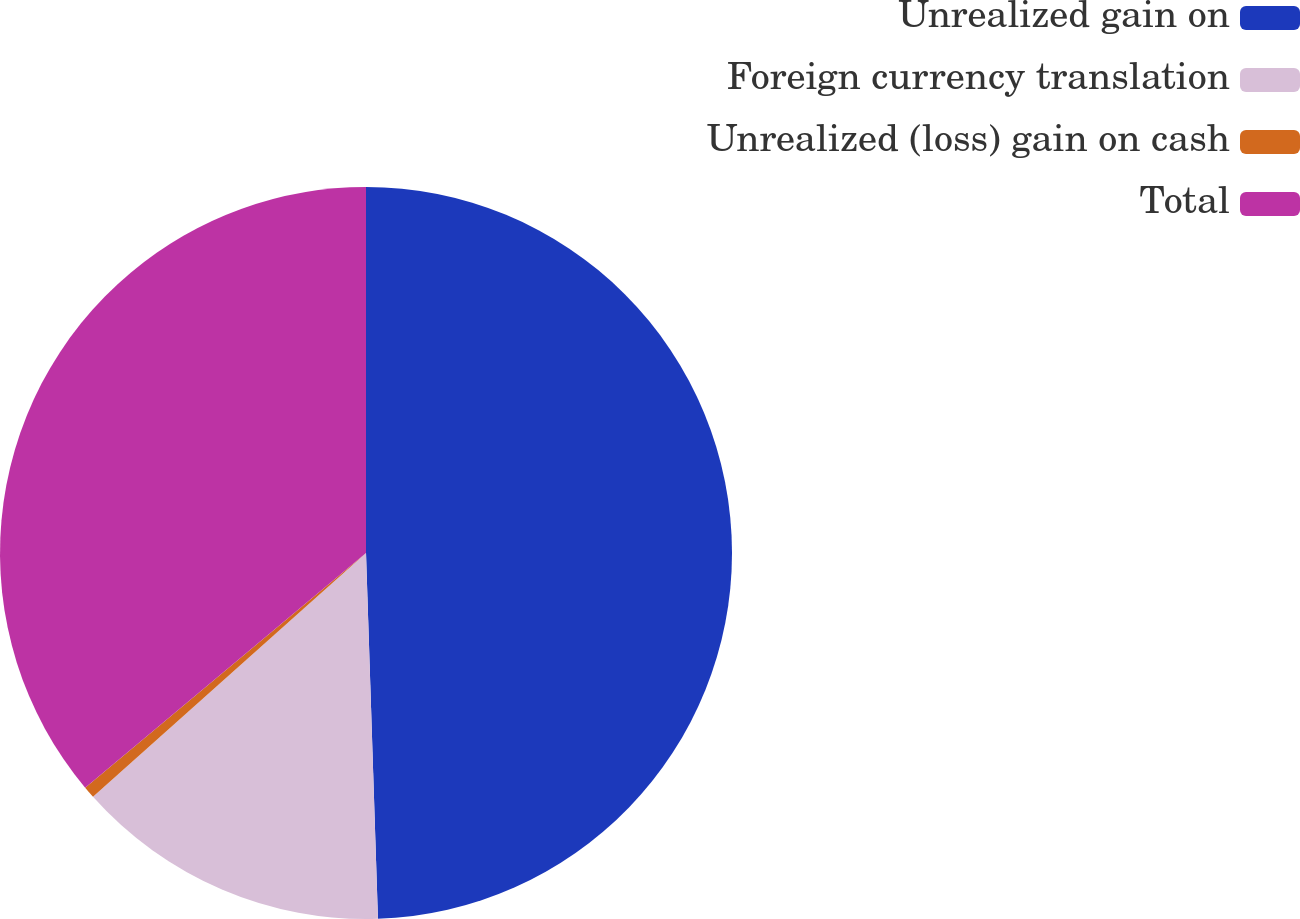Convert chart to OTSL. <chart><loc_0><loc_0><loc_500><loc_500><pie_chart><fcel>Unrealized gain on<fcel>Foreign currency translation<fcel>Unrealized (loss) gain on cash<fcel>Total<nl><fcel>49.48%<fcel>13.92%<fcel>0.52%<fcel>36.08%<nl></chart> 